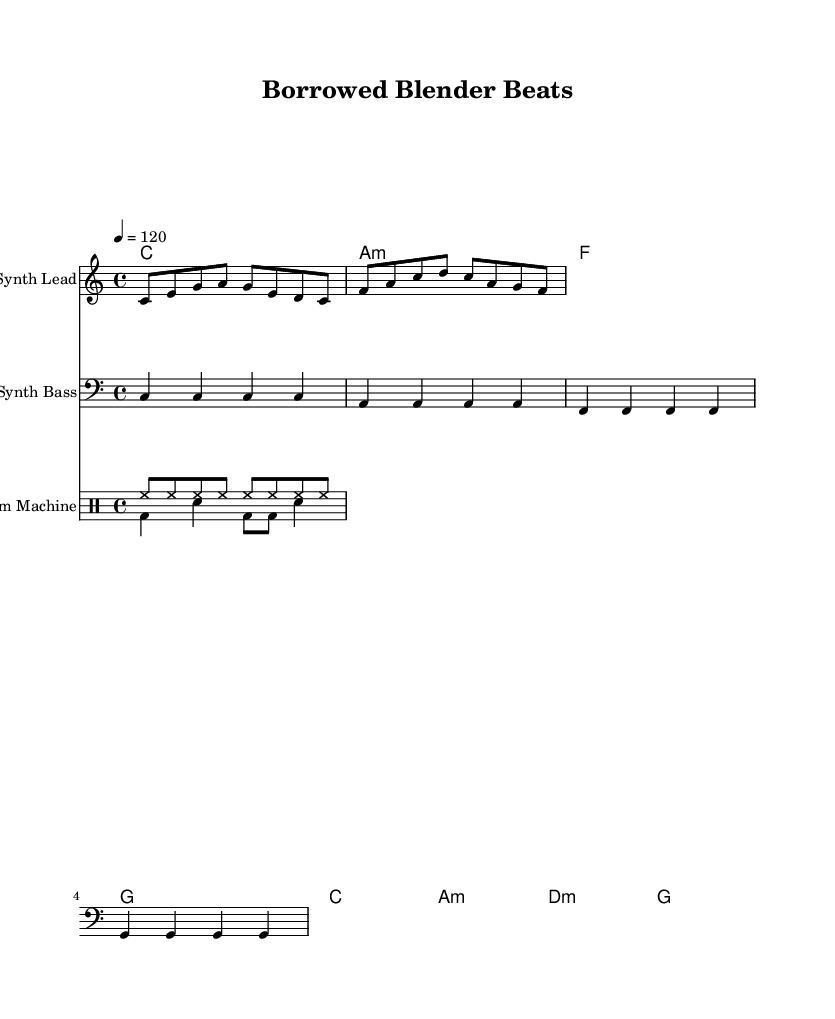What is the key signature of this music? The key signature is indicated by the absence of sharps or flats, which represents C major.
Answer: C major What is the time signature of this piece? The time signature is represented by the notation "4/4," which indicates four beats in a measure.
Answer: 4/4 What is the tempo marking of this composition? The tempo marking is shown as "4 = 120," meaning that the quarter note gets 120 beats per minute.
Answer: 120 How many measures are in the melody? By counting the number of different sections in the melody (notated by the notes), there are a total of four measures.
Answer: 4 What type of drum pattern is primarily used in the piece? The drum patterns include a combination of hi-hat and bass drum, common in electronic music, often structured with consistent rhythms.
Answer: Drum Machine What is the bass clef used for in this score? The bass clef indicates that the notes on the staff should be played by a lower-pitched instrument, providing the harmonic foundation.
Answer: Synth Bass How many instrument parts are there in this arrangement? The score contains four parts: Synth Lead, Synth Bass, and two drum voices, which together create a layered sound typical of electronic music.
Answer: 4 